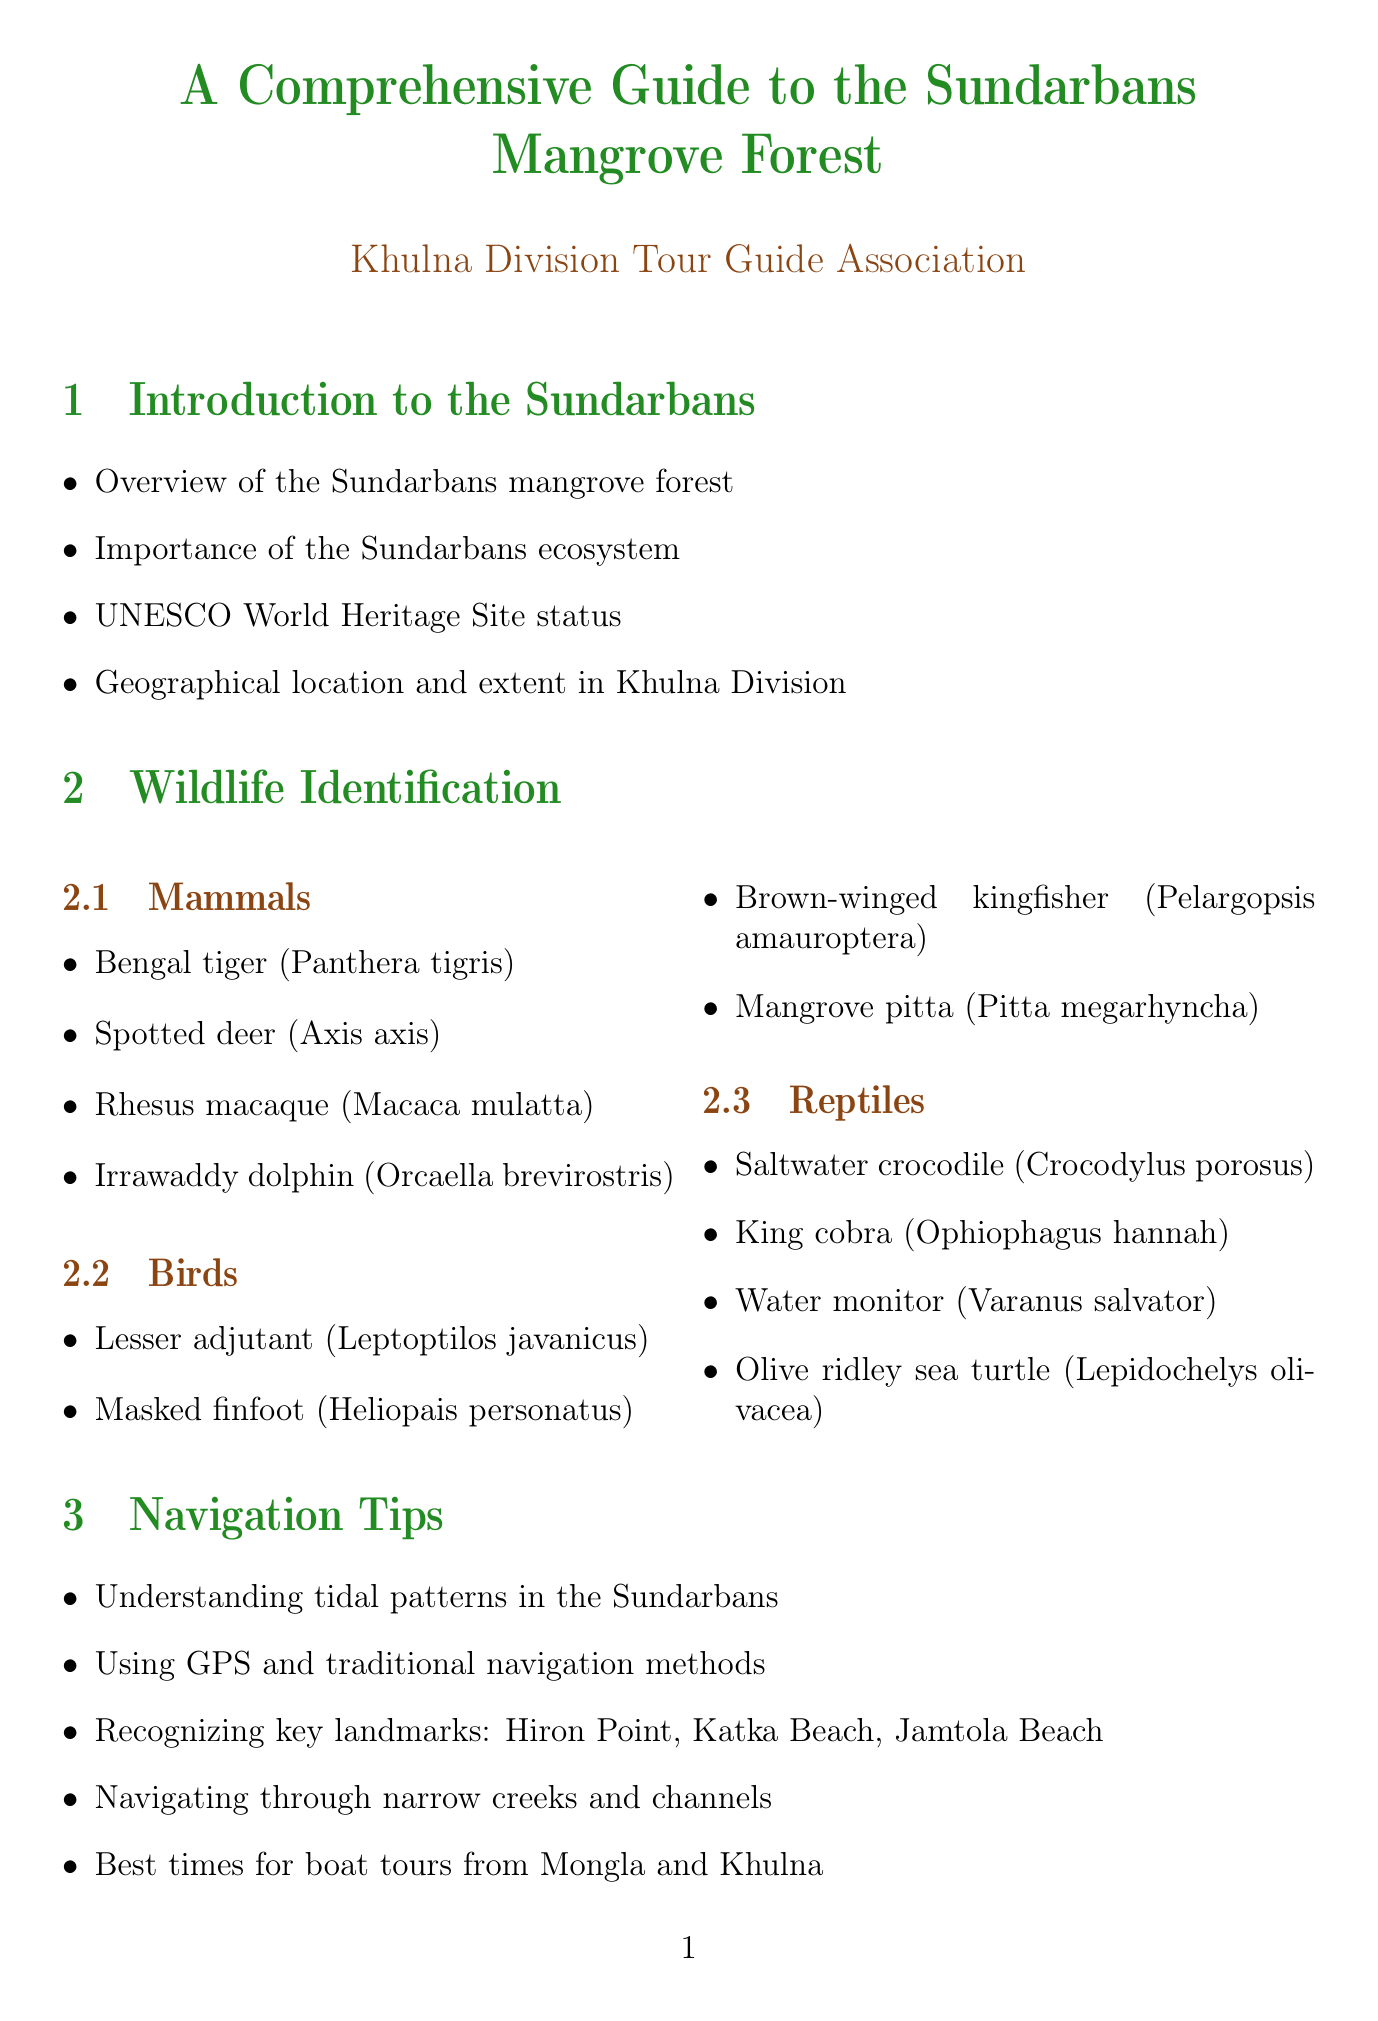What is the status of the Sundarbans? The document states that the Sundarbans is a UNESCO World Heritage Site.
Answer: UNESCO World Heritage Site How many types of mammals are listed in the wildlife identification section? The section lists four types of mammals in the Sundarbans.
Answer: 4 What is the best time to visit the Sundarbans? According to the document, the best seasons to visit are from October to March.
Answer: October to March Which community is mentioned in the local culture section? The document mentions the Munda community as part of the local culture.
Answer: Munda What safety measure is advised for encountering a tiger? The document includes guidelines specifically for tiger encounters as a safety measure.
Answer: Tiger encounter guidelines What is one of the mangrove types found in the Sundarbans? The document lists Sundari as one of the types of mangroves.
Answer: Sundari How many reptiles are identified in the wildlife identification section? The document identifies four types of reptiles in the wildlife section.
Answer: 4 What type of ecological role do mangroves play? The document states that mangroves are important for coastal protection.
Answer: Coastal protection What kind of navigation methods are suggested for the Sundarbans? The document mentions using GPS and traditional navigation methods.
Answer: GPS and traditional navigation methods 